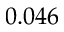<formula> <loc_0><loc_0><loc_500><loc_500>0 . 0 4 6</formula> 